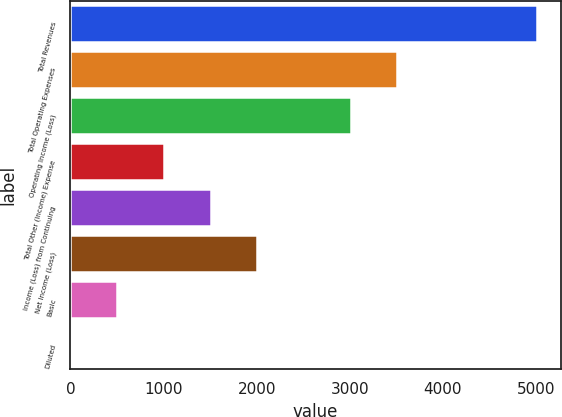Convert chart. <chart><loc_0><loc_0><loc_500><loc_500><bar_chart><fcel>Total Revenues<fcel>Total Operating Expenses<fcel>Operating Income (Loss)<fcel>Total Other (Income) Expense<fcel>Income (Loss) from Continuing<fcel>Net Income (Loss)<fcel>Basic<fcel>Diluted<nl><fcel>5015<fcel>3511.25<fcel>3010<fcel>1005<fcel>1506.25<fcel>2007.5<fcel>503.75<fcel>2.5<nl></chart> 